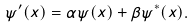Convert formula to latex. <formula><loc_0><loc_0><loc_500><loc_500>\psi ^ { \prime } ( x ) = \alpha \psi ( x ) + \beta \psi ^ { * } ( x ) .</formula> 